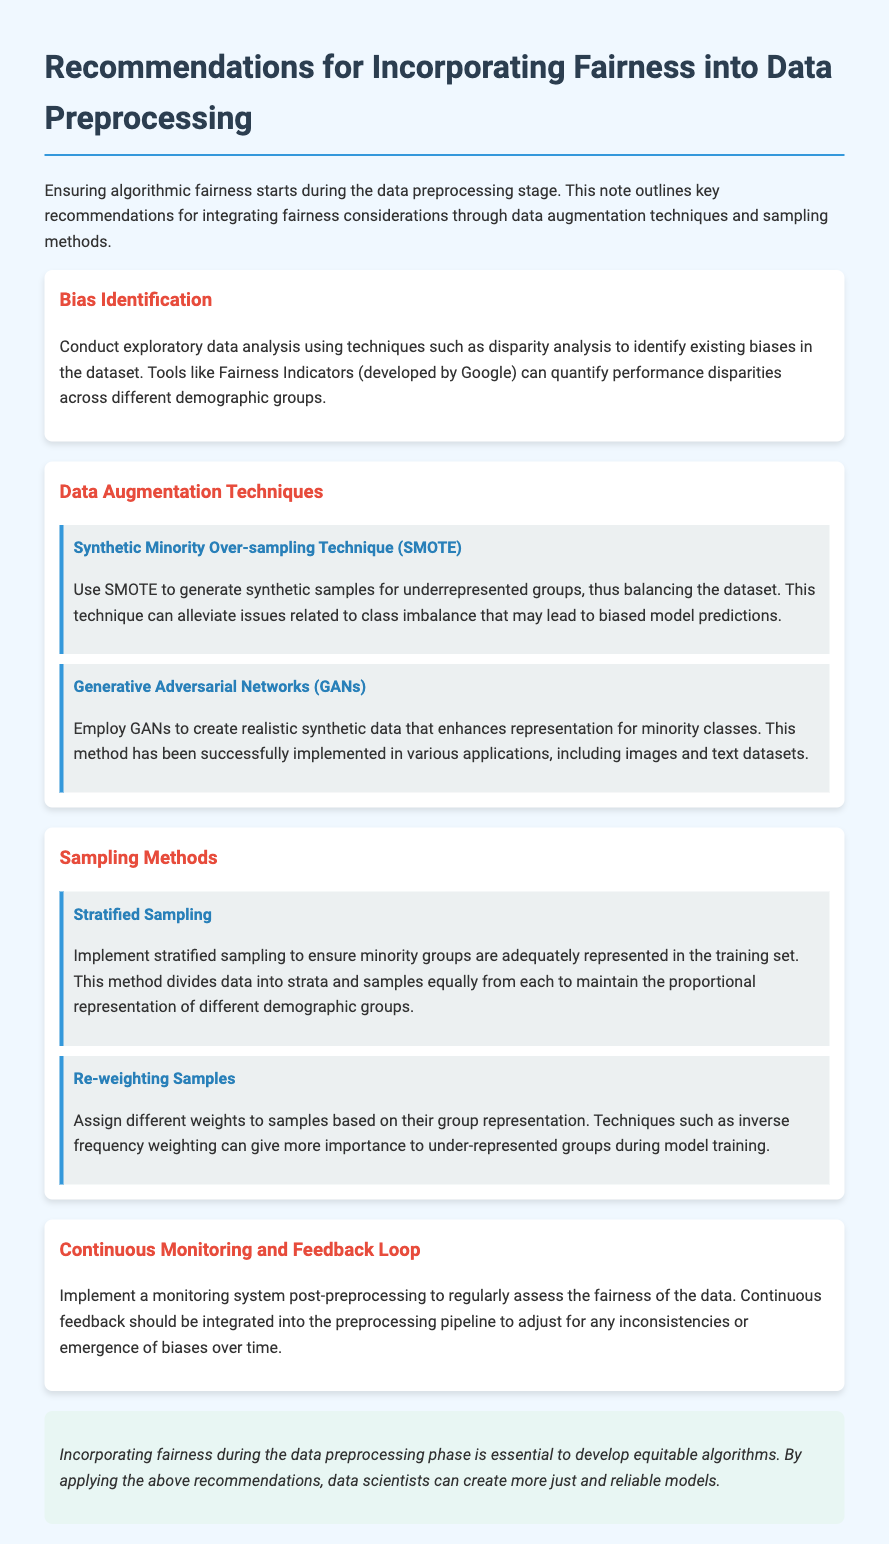What is the title of the document? The title is presented in the header section, which states the focus of the document.
Answer: Recommendations for Incorporating Fairness into Data Preprocessing What technique is suggested for generating synthetic samples? The document mentions specific techniques in the data augmentation section for addressing class imbalance.
Answer: SMOTE What does GAN stand for? The document abbreviates this term when discussing data augmentation methods and their applications.
Answer: Generative Adversarial Networks What sampling method ensures minority groups are represented? The document explicitly addresses various sampling methods, highlighting their relevance to representation in the training set.
Answer: Stratified Sampling What is suggested to monitor data fairness post-preprocessing? This recommendation emphasizes the need for ongoing evaluation after initial data processing is complete.
Answer: Monitoring system What should be assigned to samples during re-weighting methods? This recommendation focuses on adjusting the importance of different groups for model training.
Answer: Different weights How is bias identified in the dataset? The document mentions specific strategies to explore and analyze data to uncover biases effectively.
Answer: Disparity analysis 